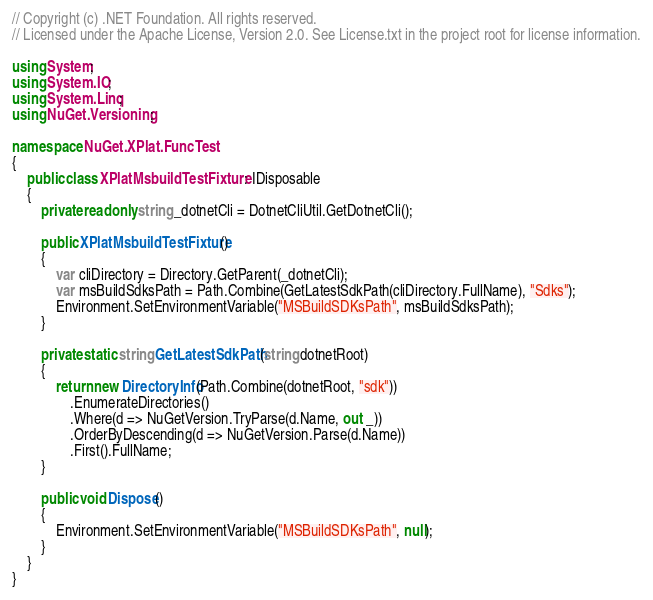<code> <loc_0><loc_0><loc_500><loc_500><_C#_>// Copyright (c) .NET Foundation. All rights reserved.
// Licensed under the Apache License, Version 2.0. See License.txt in the project root for license information.

using System;
using System.IO;
using System.Linq;
using NuGet.Versioning;

namespace NuGet.XPlat.FuncTest
{
    public class XPlatMsbuildTestFixture : IDisposable
    {
        private readonly string _dotnetCli = DotnetCliUtil.GetDotnetCli();

        public XPlatMsbuildTestFixture()
        {
            var cliDirectory = Directory.GetParent(_dotnetCli);
            var msBuildSdksPath = Path.Combine(GetLatestSdkPath(cliDirectory.FullName), "Sdks");
            Environment.SetEnvironmentVariable("MSBuildSDKsPath", msBuildSdksPath);
        }

        private static string GetLatestSdkPath(string dotnetRoot)
        {
            return new DirectoryInfo(Path.Combine(dotnetRoot, "sdk"))
                .EnumerateDirectories()
                .Where(d => NuGetVersion.TryParse(d.Name, out _))
                .OrderByDescending(d => NuGetVersion.Parse(d.Name))
                .First().FullName;
        }

        public void Dispose()
        {
            Environment.SetEnvironmentVariable("MSBuildSDKsPath", null);
        }
    }
}
</code> 